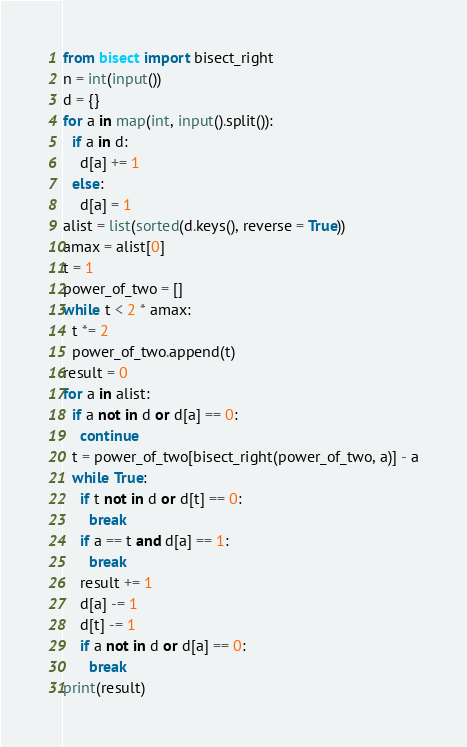<code> <loc_0><loc_0><loc_500><loc_500><_Python_>from bisect import bisect_right
n = int(input())
d = {}
for a in map(int, input().split()):
  if a in d:
    d[a] += 1
  else:
    d[a] = 1
alist = list(sorted(d.keys(), reverse = True))
amax = alist[0]
t = 1
power_of_two = []
while t < 2 * amax:
  t *= 2
  power_of_two.append(t)
result = 0
for a in alist:
  if a not in d or d[a] == 0:
    continue
  t = power_of_two[bisect_right(power_of_two, a)] - a
  while True:
    if t not in d or d[t] == 0:
      break
    if a == t and d[a] == 1:
      break
    result += 1
    d[a] -= 1
    d[t] -= 1
    if a not in d or d[a] == 0:
      break
print(result)
</code> 